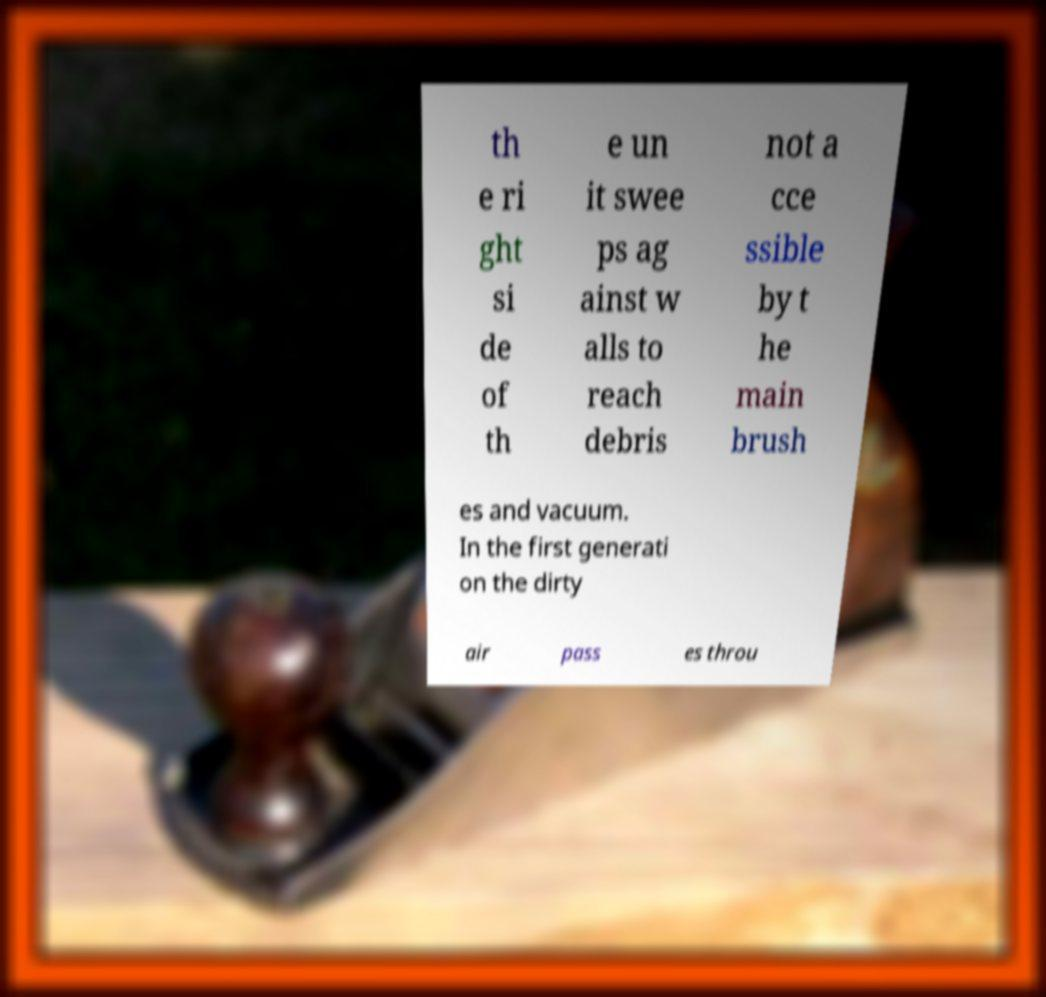I need the written content from this picture converted into text. Can you do that? th e ri ght si de of th e un it swee ps ag ainst w alls to reach debris not a cce ssible by t he main brush es and vacuum. In the first generati on the dirty air pass es throu 